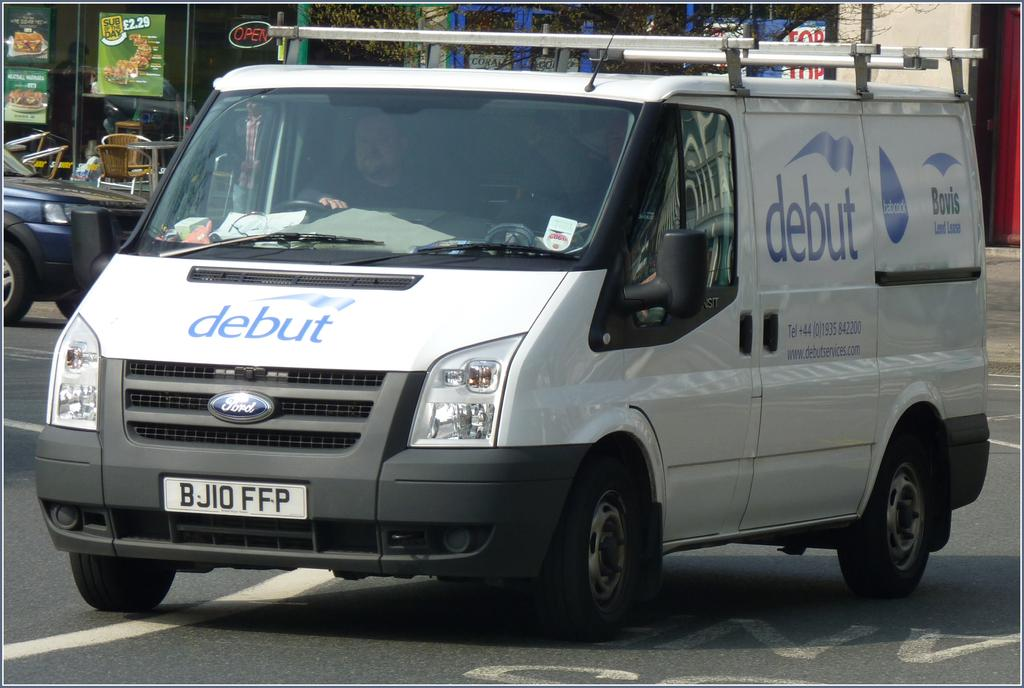<image>
Give a short and clear explanation of the subsequent image. White van which has the word Debut on the front. 